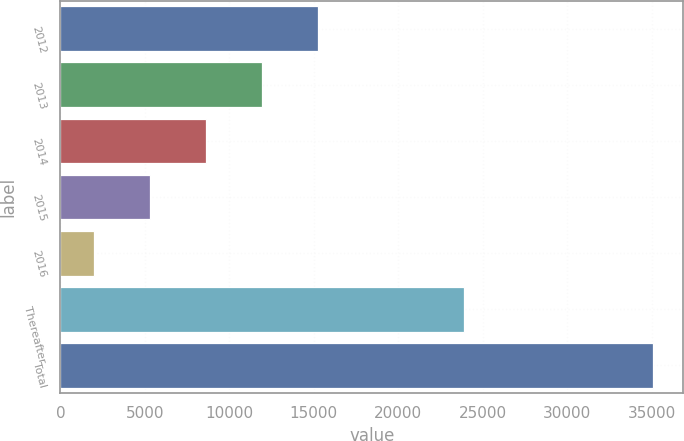Convert chart. <chart><loc_0><loc_0><loc_500><loc_500><bar_chart><fcel>2012<fcel>2013<fcel>2014<fcel>2015<fcel>2016<fcel>Thereafter<fcel>Total<nl><fcel>15230.2<fcel>11917.4<fcel>8604.6<fcel>5291.8<fcel>1979<fcel>23887<fcel>35107<nl></chart> 